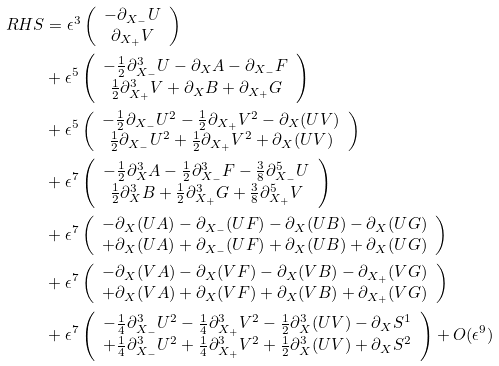<formula> <loc_0><loc_0><loc_500><loc_500>R H S & = \epsilon ^ { 3 } \left ( \begin{array} { c } - \partial _ { X _ { - } } U \\ \partial _ { X _ { + } } V \end{array} \right ) \\ & + \epsilon ^ { 5 } \left ( \begin{array} { c } - \frac { 1 } { 2 } \partial ^ { 3 } _ { X _ { - } } U - \partial _ { X } A - \partial _ { X _ { - } } F \\ \frac { 1 } { 2 } \partial ^ { 3 } _ { X _ { + } } V + \partial _ { X } B + \partial _ { X _ { + } } G \end{array} \right ) \\ & + \epsilon ^ { 5 } \left ( \begin{array} { c } - \frac { 1 } { 2 } \partial _ { X _ { - } } U ^ { 2 } - \frac { 1 } { 2 } \partial _ { X _ { + } } V ^ { 2 } - \partial _ { X } ( U V ) \\ \frac { 1 } { 2 } \partial _ { X _ { - } } U ^ { 2 } + \frac { 1 } { 2 } \partial _ { X _ { + } } V ^ { 2 } + \partial _ { X } ( U V ) \end{array} \right ) \\ & + \epsilon ^ { 7 } \left ( \begin{array} { c } - \frac { 1 } { 2 } \partial ^ { 3 } _ { X } A - \frac { 1 } { 2 } \partial ^ { 3 } _ { X _ { - } } F - \frac { 3 } { 8 } \partial ^ { 5 } _ { X _ { - } } U \\ \frac { 1 } { 2 } \partial ^ { 3 } _ { X } B + \frac { 1 } { 2 } \partial ^ { 3 } _ { X _ { + } } G + \frac { 3 } { 8 } \partial ^ { 5 } _ { X _ { + } } V \end{array} \right ) \\ & + \epsilon ^ { 7 } \left ( \begin{array} { c } - \partial _ { X } ( U A ) - \partial _ { X _ { - } } ( U F ) - \partial _ { X } ( U B ) - \partial _ { X } ( U G ) \\ + \partial _ { X } ( U A ) + \partial _ { X _ { - } } ( U F ) + \partial _ { X } ( U B ) + \partial _ { X } ( U G ) \end{array} \right ) \\ & + \epsilon ^ { 7 } \left ( \begin{array} { c } - \partial _ { X } ( V A ) - \partial _ { X } ( V F ) - \partial _ { X } ( V B ) - \partial _ { X _ { + } } ( V G ) \\ + \partial _ { X } ( V A ) + \partial _ { X } ( V F ) + \partial _ { X } ( V B ) + \partial _ { X _ { + } } ( V G ) \end{array} \right ) \\ & + \epsilon ^ { 7 } \left ( \begin{array} { c } - \frac { 1 } { 4 } \partial _ { X _ { - } } ^ { 3 } U ^ { 2 } - \frac { 1 } { 4 } \partial _ { X _ { + } } ^ { 3 } V ^ { 2 } - \frac { 1 } { 2 } \partial _ { X } ^ { 3 } ( U V ) - \partial _ { X } S ^ { 1 } \\ + \frac { 1 } { 4 } \partial _ { X _ { - } } ^ { 3 } U ^ { 2 } + \frac { 1 } { 4 } \partial _ { X _ { + } } ^ { 3 } V ^ { 2 } + \frac { 1 } { 2 } \partial _ { X } ^ { 3 } ( U V ) + \partial _ { X } S ^ { 2 } \end{array} \right ) + O ( \epsilon ^ { 9 } )</formula> 